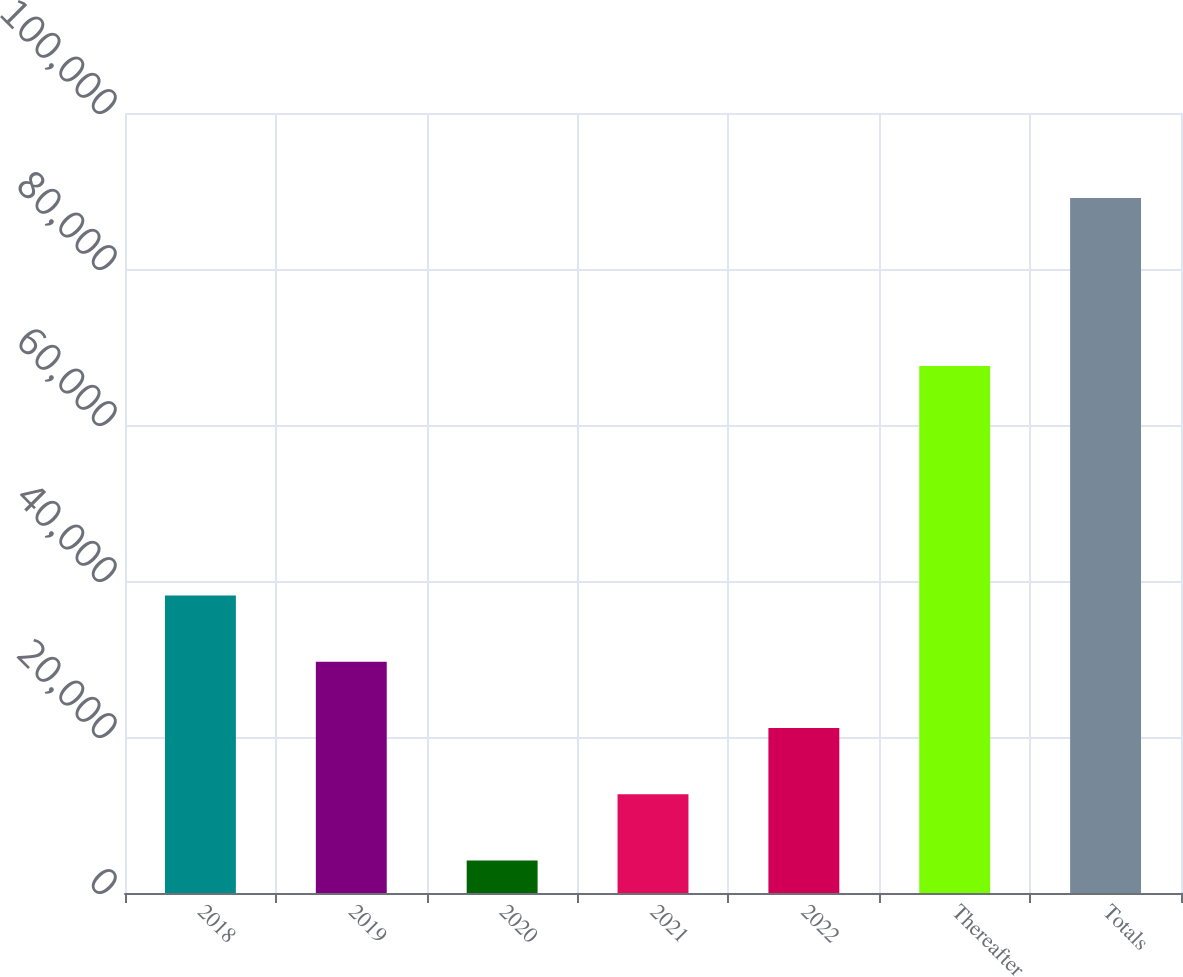<chart> <loc_0><loc_0><loc_500><loc_500><bar_chart><fcel>2018<fcel>2019<fcel>2020<fcel>2021<fcel>2022<fcel>Thereafter<fcel>Totals<nl><fcel>38145.4<fcel>29652.3<fcel>4173<fcel>12666.1<fcel>21159.2<fcel>67573<fcel>89104<nl></chart> 